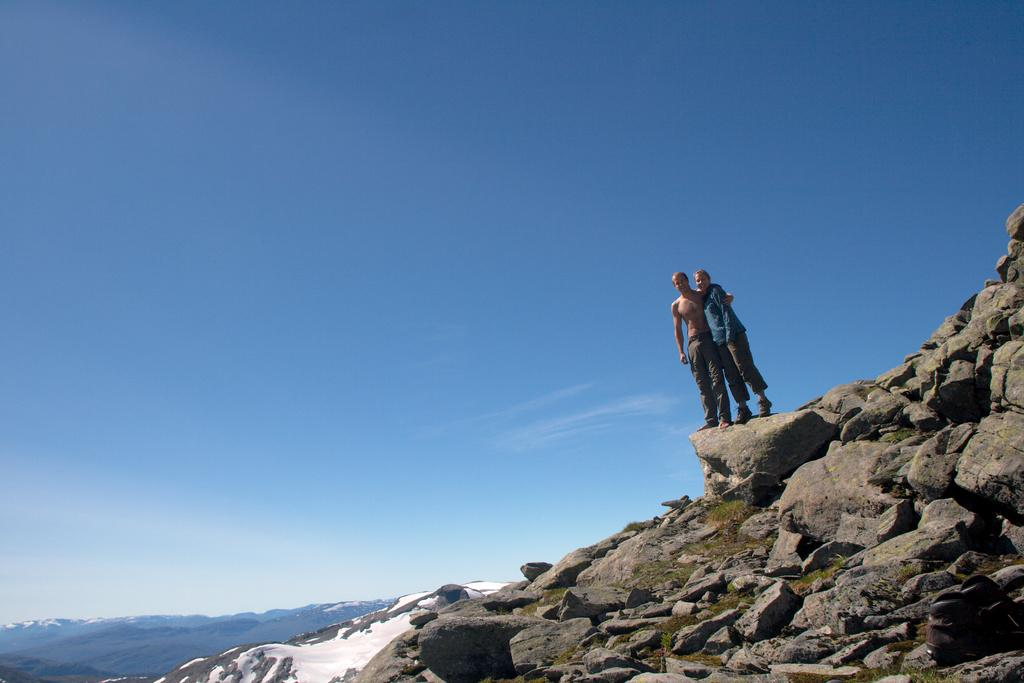How many people are in the image? There are two people in the image, a man and a woman. What are the man and woman doing in the image? Both the man and woman are standing on a rock. What type of terrain is visible in the image? There are stones and grass visible in the image. What can be seen in the background of the image? There are ice hills visible in the background. What is the condition of the sky in the image? The sky is cloudy in the image. What type of blade is the man using to cut the grass in the image? There is no blade visible in the image, and the man is not cutting grass. 